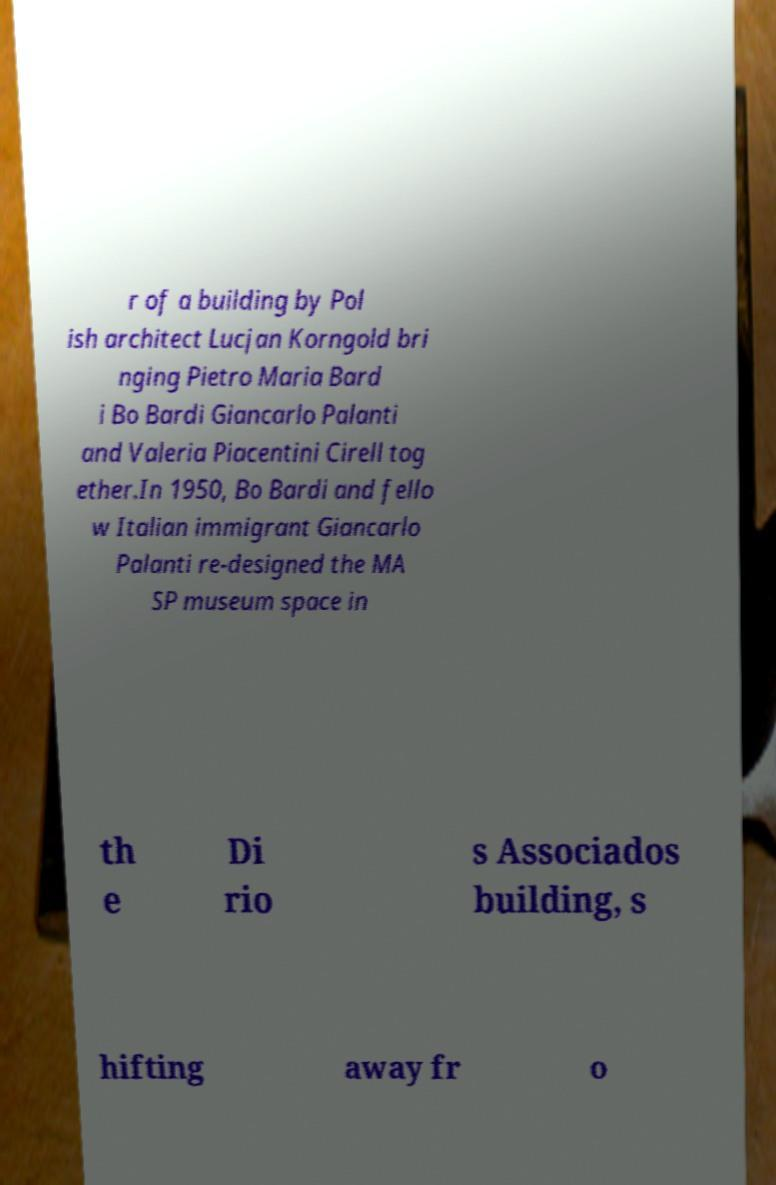Could you extract and type out the text from this image? r of a building by Pol ish architect Lucjan Korngold bri nging Pietro Maria Bard i Bo Bardi Giancarlo Palanti and Valeria Piacentini Cirell tog ether.In 1950, Bo Bardi and fello w Italian immigrant Giancarlo Palanti re-designed the MA SP museum space in th e Di rio s Associados building, s hifting away fr o 